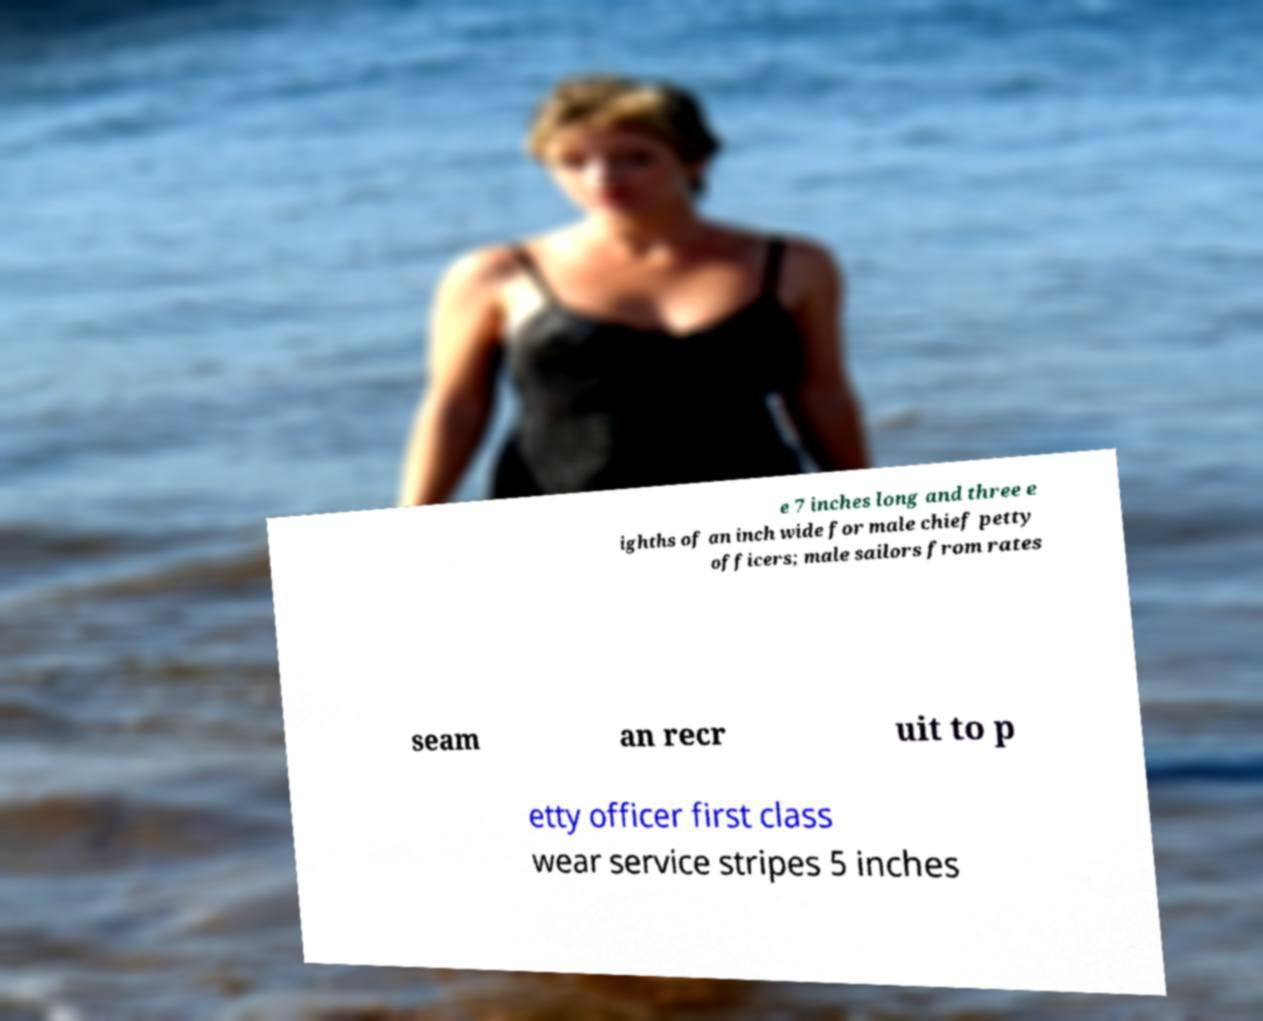Could you assist in decoding the text presented in this image and type it out clearly? e 7 inches long and three e ighths of an inch wide for male chief petty officers; male sailors from rates seam an recr uit to p etty officer first class wear service stripes 5 inches 